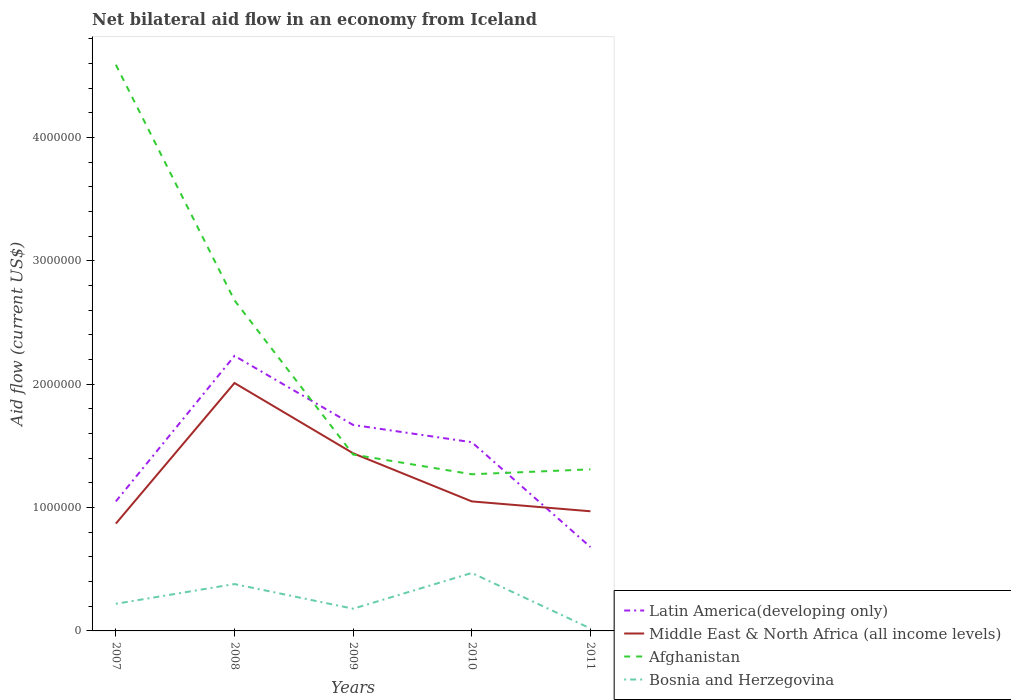Is the number of lines equal to the number of legend labels?
Keep it short and to the point. Yes. Across all years, what is the maximum net bilateral aid flow in Latin America(developing only)?
Offer a very short reply. 6.80e+05. In which year was the net bilateral aid flow in Middle East & North Africa (all income levels) maximum?
Give a very brief answer. 2007. What is the total net bilateral aid flow in Middle East & North Africa (all income levels) in the graph?
Ensure brevity in your answer.  4.70e+05. What is the difference between the highest and the second highest net bilateral aid flow in Middle East & North Africa (all income levels)?
Your answer should be compact. 1.14e+06. What is the difference between the highest and the lowest net bilateral aid flow in Middle East & North Africa (all income levels)?
Ensure brevity in your answer.  2. Is the net bilateral aid flow in Latin America(developing only) strictly greater than the net bilateral aid flow in Middle East & North Africa (all income levels) over the years?
Provide a short and direct response. No. How many lines are there?
Offer a terse response. 4. Does the graph contain any zero values?
Offer a terse response. No. Does the graph contain grids?
Provide a succinct answer. No. Where does the legend appear in the graph?
Your answer should be very brief. Bottom right. How many legend labels are there?
Your answer should be very brief. 4. How are the legend labels stacked?
Your answer should be very brief. Vertical. What is the title of the graph?
Keep it short and to the point. Net bilateral aid flow in an economy from Iceland. What is the label or title of the Y-axis?
Your answer should be compact. Aid flow (current US$). What is the Aid flow (current US$) of Latin America(developing only) in 2007?
Provide a succinct answer. 1.05e+06. What is the Aid flow (current US$) in Middle East & North Africa (all income levels) in 2007?
Provide a succinct answer. 8.70e+05. What is the Aid flow (current US$) in Afghanistan in 2007?
Provide a short and direct response. 4.59e+06. What is the Aid flow (current US$) of Bosnia and Herzegovina in 2007?
Ensure brevity in your answer.  2.20e+05. What is the Aid flow (current US$) of Latin America(developing only) in 2008?
Offer a terse response. 2.23e+06. What is the Aid flow (current US$) in Middle East & North Africa (all income levels) in 2008?
Ensure brevity in your answer.  2.01e+06. What is the Aid flow (current US$) of Afghanistan in 2008?
Your response must be concise. 2.68e+06. What is the Aid flow (current US$) in Latin America(developing only) in 2009?
Your answer should be very brief. 1.67e+06. What is the Aid flow (current US$) in Middle East & North Africa (all income levels) in 2009?
Your response must be concise. 1.44e+06. What is the Aid flow (current US$) of Afghanistan in 2009?
Offer a terse response. 1.43e+06. What is the Aid flow (current US$) of Bosnia and Herzegovina in 2009?
Your answer should be very brief. 1.80e+05. What is the Aid flow (current US$) in Latin America(developing only) in 2010?
Provide a short and direct response. 1.53e+06. What is the Aid flow (current US$) in Middle East & North Africa (all income levels) in 2010?
Your answer should be very brief. 1.05e+06. What is the Aid flow (current US$) of Afghanistan in 2010?
Your answer should be compact. 1.27e+06. What is the Aid flow (current US$) in Bosnia and Herzegovina in 2010?
Your response must be concise. 4.70e+05. What is the Aid flow (current US$) of Latin America(developing only) in 2011?
Give a very brief answer. 6.80e+05. What is the Aid flow (current US$) in Middle East & North Africa (all income levels) in 2011?
Give a very brief answer. 9.70e+05. What is the Aid flow (current US$) of Afghanistan in 2011?
Give a very brief answer. 1.31e+06. What is the Aid flow (current US$) of Bosnia and Herzegovina in 2011?
Ensure brevity in your answer.  2.00e+04. Across all years, what is the maximum Aid flow (current US$) of Latin America(developing only)?
Offer a terse response. 2.23e+06. Across all years, what is the maximum Aid flow (current US$) of Middle East & North Africa (all income levels)?
Give a very brief answer. 2.01e+06. Across all years, what is the maximum Aid flow (current US$) of Afghanistan?
Your answer should be very brief. 4.59e+06. Across all years, what is the maximum Aid flow (current US$) in Bosnia and Herzegovina?
Give a very brief answer. 4.70e+05. Across all years, what is the minimum Aid flow (current US$) in Latin America(developing only)?
Offer a very short reply. 6.80e+05. Across all years, what is the minimum Aid flow (current US$) of Middle East & North Africa (all income levels)?
Your answer should be very brief. 8.70e+05. Across all years, what is the minimum Aid flow (current US$) in Afghanistan?
Keep it short and to the point. 1.27e+06. What is the total Aid flow (current US$) of Latin America(developing only) in the graph?
Ensure brevity in your answer.  7.16e+06. What is the total Aid flow (current US$) in Middle East & North Africa (all income levels) in the graph?
Ensure brevity in your answer.  6.34e+06. What is the total Aid flow (current US$) in Afghanistan in the graph?
Keep it short and to the point. 1.13e+07. What is the total Aid flow (current US$) of Bosnia and Herzegovina in the graph?
Provide a succinct answer. 1.27e+06. What is the difference between the Aid flow (current US$) in Latin America(developing only) in 2007 and that in 2008?
Your response must be concise. -1.18e+06. What is the difference between the Aid flow (current US$) of Middle East & North Africa (all income levels) in 2007 and that in 2008?
Provide a succinct answer. -1.14e+06. What is the difference between the Aid flow (current US$) in Afghanistan in 2007 and that in 2008?
Keep it short and to the point. 1.91e+06. What is the difference between the Aid flow (current US$) of Bosnia and Herzegovina in 2007 and that in 2008?
Your answer should be very brief. -1.60e+05. What is the difference between the Aid flow (current US$) of Latin America(developing only) in 2007 and that in 2009?
Your answer should be very brief. -6.20e+05. What is the difference between the Aid flow (current US$) of Middle East & North Africa (all income levels) in 2007 and that in 2009?
Your answer should be very brief. -5.70e+05. What is the difference between the Aid flow (current US$) of Afghanistan in 2007 and that in 2009?
Your answer should be compact. 3.16e+06. What is the difference between the Aid flow (current US$) in Latin America(developing only) in 2007 and that in 2010?
Give a very brief answer. -4.80e+05. What is the difference between the Aid flow (current US$) of Afghanistan in 2007 and that in 2010?
Your response must be concise. 3.32e+06. What is the difference between the Aid flow (current US$) in Middle East & North Africa (all income levels) in 2007 and that in 2011?
Your answer should be compact. -1.00e+05. What is the difference between the Aid flow (current US$) in Afghanistan in 2007 and that in 2011?
Your answer should be very brief. 3.28e+06. What is the difference between the Aid flow (current US$) of Latin America(developing only) in 2008 and that in 2009?
Give a very brief answer. 5.60e+05. What is the difference between the Aid flow (current US$) of Middle East & North Africa (all income levels) in 2008 and that in 2009?
Offer a very short reply. 5.70e+05. What is the difference between the Aid flow (current US$) in Afghanistan in 2008 and that in 2009?
Keep it short and to the point. 1.25e+06. What is the difference between the Aid flow (current US$) in Bosnia and Herzegovina in 2008 and that in 2009?
Your response must be concise. 2.00e+05. What is the difference between the Aid flow (current US$) of Middle East & North Africa (all income levels) in 2008 and that in 2010?
Ensure brevity in your answer.  9.60e+05. What is the difference between the Aid flow (current US$) of Afghanistan in 2008 and that in 2010?
Your response must be concise. 1.41e+06. What is the difference between the Aid flow (current US$) of Bosnia and Herzegovina in 2008 and that in 2010?
Ensure brevity in your answer.  -9.00e+04. What is the difference between the Aid flow (current US$) of Latin America(developing only) in 2008 and that in 2011?
Ensure brevity in your answer.  1.55e+06. What is the difference between the Aid flow (current US$) in Middle East & North Africa (all income levels) in 2008 and that in 2011?
Provide a short and direct response. 1.04e+06. What is the difference between the Aid flow (current US$) of Afghanistan in 2008 and that in 2011?
Provide a succinct answer. 1.37e+06. What is the difference between the Aid flow (current US$) of Bosnia and Herzegovina in 2008 and that in 2011?
Your answer should be compact. 3.60e+05. What is the difference between the Aid flow (current US$) of Latin America(developing only) in 2009 and that in 2010?
Make the answer very short. 1.40e+05. What is the difference between the Aid flow (current US$) in Afghanistan in 2009 and that in 2010?
Your answer should be very brief. 1.60e+05. What is the difference between the Aid flow (current US$) of Bosnia and Herzegovina in 2009 and that in 2010?
Provide a succinct answer. -2.90e+05. What is the difference between the Aid flow (current US$) in Latin America(developing only) in 2009 and that in 2011?
Keep it short and to the point. 9.90e+05. What is the difference between the Aid flow (current US$) of Afghanistan in 2009 and that in 2011?
Provide a short and direct response. 1.20e+05. What is the difference between the Aid flow (current US$) in Bosnia and Herzegovina in 2009 and that in 2011?
Your answer should be compact. 1.60e+05. What is the difference between the Aid flow (current US$) in Latin America(developing only) in 2010 and that in 2011?
Keep it short and to the point. 8.50e+05. What is the difference between the Aid flow (current US$) in Middle East & North Africa (all income levels) in 2010 and that in 2011?
Ensure brevity in your answer.  8.00e+04. What is the difference between the Aid flow (current US$) of Afghanistan in 2010 and that in 2011?
Make the answer very short. -4.00e+04. What is the difference between the Aid flow (current US$) of Latin America(developing only) in 2007 and the Aid flow (current US$) of Middle East & North Africa (all income levels) in 2008?
Your answer should be compact. -9.60e+05. What is the difference between the Aid flow (current US$) of Latin America(developing only) in 2007 and the Aid flow (current US$) of Afghanistan in 2008?
Your answer should be very brief. -1.63e+06. What is the difference between the Aid flow (current US$) in Latin America(developing only) in 2007 and the Aid flow (current US$) in Bosnia and Herzegovina in 2008?
Your answer should be compact. 6.70e+05. What is the difference between the Aid flow (current US$) of Middle East & North Africa (all income levels) in 2007 and the Aid flow (current US$) of Afghanistan in 2008?
Your response must be concise. -1.81e+06. What is the difference between the Aid flow (current US$) in Middle East & North Africa (all income levels) in 2007 and the Aid flow (current US$) in Bosnia and Herzegovina in 2008?
Your answer should be very brief. 4.90e+05. What is the difference between the Aid flow (current US$) in Afghanistan in 2007 and the Aid flow (current US$) in Bosnia and Herzegovina in 2008?
Ensure brevity in your answer.  4.21e+06. What is the difference between the Aid flow (current US$) in Latin America(developing only) in 2007 and the Aid flow (current US$) in Middle East & North Africa (all income levels) in 2009?
Your answer should be very brief. -3.90e+05. What is the difference between the Aid flow (current US$) in Latin America(developing only) in 2007 and the Aid flow (current US$) in Afghanistan in 2009?
Offer a very short reply. -3.80e+05. What is the difference between the Aid flow (current US$) in Latin America(developing only) in 2007 and the Aid flow (current US$) in Bosnia and Herzegovina in 2009?
Offer a very short reply. 8.70e+05. What is the difference between the Aid flow (current US$) in Middle East & North Africa (all income levels) in 2007 and the Aid flow (current US$) in Afghanistan in 2009?
Your answer should be compact. -5.60e+05. What is the difference between the Aid flow (current US$) in Middle East & North Africa (all income levels) in 2007 and the Aid flow (current US$) in Bosnia and Herzegovina in 2009?
Your answer should be very brief. 6.90e+05. What is the difference between the Aid flow (current US$) in Afghanistan in 2007 and the Aid flow (current US$) in Bosnia and Herzegovina in 2009?
Make the answer very short. 4.41e+06. What is the difference between the Aid flow (current US$) of Latin America(developing only) in 2007 and the Aid flow (current US$) of Middle East & North Africa (all income levels) in 2010?
Offer a very short reply. 0. What is the difference between the Aid flow (current US$) of Latin America(developing only) in 2007 and the Aid flow (current US$) of Afghanistan in 2010?
Provide a succinct answer. -2.20e+05. What is the difference between the Aid flow (current US$) in Latin America(developing only) in 2007 and the Aid flow (current US$) in Bosnia and Herzegovina in 2010?
Offer a very short reply. 5.80e+05. What is the difference between the Aid flow (current US$) of Middle East & North Africa (all income levels) in 2007 and the Aid flow (current US$) of Afghanistan in 2010?
Your answer should be very brief. -4.00e+05. What is the difference between the Aid flow (current US$) of Middle East & North Africa (all income levels) in 2007 and the Aid flow (current US$) of Bosnia and Herzegovina in 2010?
Your response must be concise. 4.00e+05. What is the difference between the Aid flow (current US$) of Afghanistan in 2007 and the Aid flow (current US$) of Bosnia and Herzegovina in 2010?
Your answer should be very brief. 4.12e+06. What is the difference between the Aid flow (current US$) in Latin America(developing only) in 2007 and the Aid flow (current US$) in Middle East & North Africa (all income levels) in 2011?
Offer a very short reply. 8.00e+04. What is the difference between the Aid flow (current US$) of Latin America(developing only) in 2007 and the Aid flow (current US$) of Bosnia and Herzegovina in 2011?
Your answer should be very brief. 1.03e+06. What is the difference between the Aid flow (current US$) of Middle East & North Africa (all income levels) in 2007 and the Aid flow (current US$) of Afghanistan in 2011?
Ensure brevity in your answer.  -4.40e+05. What is the difference between the Aid flow (current US$) in Middle East & North Africa (all income levels) in 2007 and the Aid flow (current US$) in Bosnia and Herzegovina in 2011?
Your answer should be very brief. 8.50e+05. What is the difference between the Aid flow (current US$) of Afghanistan in 2007 and the Aid flow (current US$) of Bosnia and Herzegovina in 2011?
Give a very brief answer. 4.57e+06. What is the difference between the Aid flow (current US$) in Latin America(developing only) in 2008 and the Aid flow (current US$) in Middle East & North Africa (all income levels) in 2009?
Keep it short and to the point. 7.90e+05. What is the difference between the Aid flow (current US$) of Latin America(developing only) in 2008 and the Aid flow (current US$) of Bosnia and Herzegovina in 2009?
Keep it short and to the point. 2.05e+06. What is the difference between the Aid flow (current US$) of Middle East & North Africa (all income levels) in 2008 and the Aid flow (current US$) of Afghanistan in 2009?
Make the answer very short. 5.80e+05. What is the difference between the Aid flow (current US$) of Middle East & North Africa (all income levels) in 2008 and the Aid flow (current US$) of Bosnia and Herzegovina in 2009?
Provide a succinct answer. 1.83e+06. What is the difference between the Aid flow (current US$) in Afghanistan in 2008 and the Aid flow (current US$) in Bosnia and Herzegovina in 2009?
Provide a succinct answer. 2.50e+06. What is the difference between the Aid flow (current US$) of Latin America(developing only) in 2008 and the Aid flow (current US$) of Middle East & North Africa (all income levels) in 2010?
Provide a short and direct response. 1.18e+06. What is the difference between the Aid flow (current US$) in Latin America(developing only) in 2008 and the Aid flow (current US$) in Afghanistan in 2010?
Your answer should be compact. 9.60e+05. What is the difference between the Aid flow (current US$) of Latin America(developing only) in 2008 and the Aid flow (current US$) of Bosnia and Herzegovina in 2010?
Offer a very short reply. 1.76e+06. What is the difference between the Aid flow (current US$) in Middle East & North Africa (all income levels) in 2008 and the Aid flow (current US$) in Afghanistan in 2010?
Give a very brief answer. 7.40e+05. What is the difference between the Aid flow (current US$) of Middle East & North Africa (all income levels) in 2008 and the Aid flow (current US$) of Bosnia and Herzegovina in 2010?
Provide a short and direct response. 1.54e+06. What is the difference between the Aid flow (current US$) in Afghanistan in 2008 and the Aid flow (current US$) in Bosnia and Herzegovina in 2010?
Offer a terse response. 2.21e+06. What is the difference between the Aid flow (current US$) of Latin America(developing only) in 2008 and the Aid flow (current US$) of Middle East & North Africa (all income levels) in 2011?
Your response must be concise. 1.26e+06. What is the difference between the Aid flow (current US$) of Latin America(developing only) in 2008 and the Aid flow (current US$) of Afghanistan in 2011?
Your answer should be compact. 9.20e+05. What is the difference between the Aid flow (current US$) in Latin America(developing only) in 2008 and the Aid flow (current US$) in Bosnia and Herzegovina in 2011?
Offer a very short reply. 2.21e+06. What is the difference between the Aid flow (current US$) in Middle East & North Africa (all income levels) in 2008 and the Aid flow (current US$) in Bosnia and Herzegovina in 2011?
Your answer should be very brief. 1.99e+06. What is the difference between the Aid flow (current US$) of Afghanistan in 2008 and the Aid flow (current US$) of Bosnia and Herzegovina in 2011?
Make the answer very short. 2.66e+06. What is the difference between the Aid flow (current US$) of Latin America(developing only) in 2009 and the Aid flow (current US$) of Middle East & North Africa (all income levels) in 2010?
Provide a succinct answer. 6.20e+05. What is the difference between the Aid flow (current US$) in Latin America(developing only) in 2009 and the Aid flow (current US$) in Bosnia and Herzegovina in 2010?
Make the answer very short. 1.20e+06. What is the difference between the Aid flow (current US$) in Middle East & North Africa (all income levels) in 2009 and the Aid flow (current US$) in Afghanistan in 2010?
Provide a succinct answer. 1.70e+05. What is the difference between the Aid flow (current US$) of Middle East & North Africa (all income levels) in 2009 and the Aid flow (current US$) of Bosnia and Herzegovina in 2010?
Provide a short and direct response. 9.70e+05. What is the difference between the Aid flow (current US$) in Afghanistan in 2009 and the Aid flow (current US$) in Bosnia and Herzegovina in 2010?
Give a very brief answer. 9.60e+05. What is the difference between the Aid flow (current US$) of Latin America(developing only) in 2009 and the Aid flow (current US$) of Bosnia and Herzegovina in 2011?
Ensure brevity in your answer.  1.65e+06. What is the difference between the Aid flow (current US$) of Middle East & North Africa (all income levels) in 2009 and the Aid flow (current US$) of Bosnia and Herzegovina in 2011?
Offer a very short reply. 1.42e+06. What is the difference between the Aid flow (current US$) of Afghanistan in 2009 and the Aid flow (current US$) of Bosnia and Herzegovina in 2011?
Offer a terse response. 1.41e+06. What is the difference between the Aid flow (current US$) in Latin America(developing only) in 2010 and the Aid flow (current US$) in Middle East & North Africa (all income levels) in 2011?
Keep it short and to the point. 5.60e+05. What is the difference between the Aid flow (current US$) in Latin America(developing only) in 2010 and the Aid flow (current US$) in Bosnia and Herzegovina in 2011?
Keep it short and to the point. 1.51e+06. What is the difference between the Aid flow (current US$) in Middle East & North Africa (all income levels) in 2010 and the Aid flow (current US$) in Afghanistan in 2011?
Offer a very short reply. -2.60e+05. What is the difference between the Aid flow (current US$) in Middle East & North Africa (all income levels) in 2010 and the Aid flow (current US$) in Bosnia and Herzegovina in 2011?
Keep it short and to the point. 1.03e+06. What is the difference between the Aid flow (current US$) of Afghanistan in 2010 and the Aid flow (current US$) of Bosnia and Herzegovina in 2011?
Your answer should be very brief. 1.25e+06. What is the average Aid flow (current US$) of Latin America(developing only) per year?
Provide a short and direct response. 1.43e+06. What is the average Aid flow (current US$) in Middle East & North Africa (all income levels) per year?
Offer a very short reply. 1.27e+06. What is the average Aid flow (current US$) in Afghanistan per year?
Ensure brevity in your answer.  2.26e+06. What is the average Aid flow (current US$) in Bosnia and Herzegovina per year?
Your response must be concise. 2.54e+05. In the year 2007, what is the difference between the Aid flow (current US$) in Latin America(developing only) and Aid flow (current US$) in Afghanistan?
Offer a terse response. -3.54e+06. In the year 2007, what is the difference between the Aid flow (current US$) of Latin America(developing only) and Aid flow (current US$) of Bosnia and Herzegovina?
Make the answer very short. 8.30e+05. In the year 2007, what is the difference between the Aid flow (current US$) in Middle East & North Africa (all income levels) and Aid flow (current US$) in Afghanistan?
Your answer should be compact. -3.72e+06. In the year 2007, what is the difference between the Aid flow (current US$) in Middle East & North Africa (all income levels) and Aid flow (current US$) in Bosnia and Herzegovina?
Offer a very short reply. 6.50e+05. In the year 2007, what is the difference between the Aid flow (current US$) of Afghanistan and Aid flow (current US$) of Bosnia and Herzegovina?
Offer a very short reply. 4.37e+06. In the year 2008, what is the difference between the Aid flow (current US$) in Latin America(developing only) and Aid flow (current US$) in Afghanistan?
Your answer should be very brief. -4.50e+05. In the year 2008, what is the difference between the Aid flow (current US$) of Latin America(developing only) and Aid flow (current US$) of Bosnia and Herzegovina?
Offer a very short reply. 1.85e+06. In the year 2008, what is the difference between the Aid flow (current US$) of Middle East & North Africa (all income levels) and Aid flow (current US$) of Afghanistan?
Your answer should be very brief. -6.70e+05. In the year 2008, what is the difference between the Aid flow (current US$) in Middle East & North Africa (all income levels) and Aid flow (current US$) in Bosnia and Herzegovina?
Give a very brief answer. 1.63e+06. In the year 2008, what is the difference between the Aid flow (current US$) in Afghanistan and Aid flow (current US$) in Bosnia and Herzegovina?
Keep it short and to the point. 2.30e+06. In the year 2009, what is the difference between the Aid flow (current US$) in Latin America(developing only) and Aid flow (current US$) in Middle East & North Africa (all income levels)?
Provide a succinct answer. 2.30e+05. In the year 2009, what is the difference between the Aid flow (current US$) of Latin America(developing only) and Aid flow (current US$) of Afghanistan?
Offer a very short reply. 2.40e+05. In the year 2009, what is the difference between the Aid flow (current US$) of Latin America(developing only) and Aid flow (current US$) of Bosnia and Herzegovina?
Keep it short and to the point. 1.49e+06. In the year 2009, what is the difference between the Aid flow (current US$) of Middle East & North Africa (all income levels) and Aid flow (current US$) of Bosnia and Herzegovina?
Provide a succinct answer. 1.26e+06. In the year 2009, what is the difference between the Aid flow (current US$) of Afghanistan and Aid flow (current US$) of Bosnia and Herzegovina?
Keep it short and to the point. 1.25e+06. In the year 2010, what is the difference between the Aid flow (current US$) of Latin America(developing only) and Aid flow (current US$) of Middle East & North Africa (all income levels)?
Ensure brevity in your answer.  4.80e+05. In the year 2010, what is the difference between the Aid flow (current US$) of Latin America(developing only) and Aid flow (current US$) of Afghanistan?
Your answer should be very brief. 2.60e+05. In the year 2010, what is the difference between the Aid flow (current US$) of Latin America(developing only) and Aid flow (current US$) of Bosnia and Herzegovina?
Provide a succinct answer. 1.06e+06. In the year 2010, what is the difference between the Aid flow (current US$) in Middle East & North Africa (all income levels) and Aid flow (current US$) in Afghanistan?
Your answer should be very brief. -2.20e+05. In the year 2010, what is the difference between the Aid flow (current US$) in Middle East & North Africa (all income levels) and Aid flow (current US$) in Bosnia and Herzegovina?
Provide a succinct answer. 5.80e+05. In the year 2010, what is the difference between the Aid flow (current US$) in Afghanistan and Aid flow (current US$) in Bosnia and Herzegovina?
Provide a succinct answer. 8.00e+05. In the year 2011, what is the difference between the Aid flow (current US$) in Latin America(developing only) and Aid flow (current US$) in Middle East & North Africa (all income levels)?
Your answer should be compact. -2.90e+05. In the year 2011, what is the difference between the Aid flow (current US$) of Latin America(developing only) and Aid flow (current US$) of Afghanistan?
Your answer should be very brief. -6.30e+05. In the year 2011, what is the difference between the Aid flow (current US$) of Latin America(developing only) and Aid flow (current US$) of Bosnia and Herzegovina?
Your answer should be compact. 6.60e+05. In the year 2011, what is the difference between the Aid flow (current US$) of Middle East & North Africa (all income levels) and Aid flow (current US$) of Afghanistan?
Keep it short and to the point. -3.40e+05. In the year 2011, what is the difference between the Aid flow (current US$) in Middle East & North Africa (all income levels) and Aid flow (current US$) in Bosnia and Herzegovina?
Give a very brief answer. 9.50e+05. In the year 2011, what is the difference between the Aid flow (current US$) in Afghanistan and Aid flow (current US$) in Bosnia and Herzegovina?
Your answer should be very brief. 1.29e+06. What is the ratio of the Aid flow (current US$) of Latin America(developing only) in 2007 to that in 2008?
Provide a succinct answer. 0.47. What is the ratio of the Aid flow (current US$) in Middle East & North Africa (all income levels) in 2007 to that in 2008?
Provide a succinct answer. 0.43. What is the ratio of the Aid flow (current US$) of Afghanistan in 2007 to that in 2008?
Make the answer very short. 1.71. What is the ratio of the Aid flow (current US$) in Bosnia and Herzegovina in 2007 to that in 2008?
Your answer should be compact. 0.58. What is the ratio of the Aid flow (current US$) of Latin America(developing only) in 2007 to that in 2009?
Offer a very short reply. 0.63. What is the ratio of the Aid flow (current US$) in Middle East & North Africa (all income levels) in 2007 to that in 2009?
Ensure brevity in your answer.  0.6. What is the ratio of the Aid flow (current US$) in Afghanistan in 2007 to that in 2009?
Your response must be concise. 3.21. What is the ratio of the Aid flow (current US$) in Bosnia and Herzegovina in 2007 to that in 2009?
Your response must be concise. 1.22. What is the ratio of the Aid flow (current US$) of Latin America(developing only) in 2007 to that in 2010?
Offer a very short reply. 0.69. What is the ratio of the Aid flow (current US$) of Middle East & North Africa (all income levels) in 2007 to that in 2010?
Your answer should be very brief. 0.83. What is the ratio of the Aid flow (current US$) in Afghanistan in 2007 to that in 2010?
Your answer should be very brief. 3.61. What is the ratio of the Aid flow (current US$) in Bosnia and Herzegovina in 2007 to that in 2010?
Make the answer very short. 0.47. What is the ratio of the Aid flow (current US$) in Latin America(developing only) in 2007 to that in 2011?
Give a very brief answer. 1.54. What is the ratio of the Aid flow (current US$) of Middle East & North Africa (all income levels) in 2007 to that in 2011?
Offer a very short reply. 0.9. What is the ratio of the Aid flow (current US$) in Afghanistan in 2007 to that in 2011?
Your answer should be compact. 3.5. What is the ratio of the Aid flow (current US$) in Bosnia and Herzegovina in 2007 to that in 2011?
Make the answer very short. 11. What is the ratio of the Aid flow (current US$) of Latin America(developing only) in 2008 to that in 2009?
Offer a terse response. 1.34. What is the ratio of the Aid flow (current US$) of Middle East & North Africa (all income levels) in 2008 to that in 2009?
Provide a succinct answer. 1.4. What is the ratio of the Aid flow (current US$) of Afghanistan in 2008 to that in 2009?
Your response must be concise. 1.87. What is the ratio of the Aid flow (current US$) of Bosnia and Herzegovina in 2008 to that in 2009?
Keep it short and to the point. 2.11. What is the ratio of the Aid flow (current US$) in Latin America(developing only) in 2008 to that in 2010?
Offer a terse response. 1.46. What is the ratio of the Aid flow (current US$) in Middle East & North Africa (all income levels) in 2008 to that in 2010?
Your response must be concise. 1.91. What is the ratio of the Aid flow (current US$) in Afghanistan in 2008 to that in 2010?
Make the answer very short. 2.11. What is the ratio of the Aid flow (current US$) in Bosnia and Herzegovina in 2008 to that in 2010?
Offer a terse response. 0.81. What is the ratio of the Aid flow (current US$) in Latin America(developing only) in 2008 to that in 2011?
Your answer should be very brief. 3.28. What is the ratio of the Aid flow (current US$) of Middle East & North Africa (all income levels) in 2008 to that in 2011?
Your response must be concise. 2.07. What is the ratio of the Aid flow (current US$) of Afghanistan in 2008 to that in 2011?
Make the answer very short. 2.05. What is the ratio of the Aid flow (current US$) of Bosnia and Herzegovina in 2008 to that in 2011?
Offer a very short reply. 19. What is the ratio of the Aid flow (current US$) in Latin America(developing only) in 2009 to that in 2010?
Keep it short and to the point. 1.09. What is the ratio of the Aid flow (current US$) of Middle East & North Africa (all income levels) in 2009 to that in 2010?
Provide a short and direct response. 1.37. What is the ratio of the Aid flow (current US$) of Afghanistan in 2009 to that in 2010?
Your answer should be compact. 1.13. What is the ratio of the Aid flow (current US$) in Bosnia and Herzegovina in 2009 to that in 2010?
Ensure brevity in your answer.  0.38. What is the ratio of the Aid flow (current US$) in Latin America(developing only) in 2009 to that in 2011?
Your answer should be compact. 2.46. What is the ratio of the Aid flow (current US$) of Middle East & North Africa (all income levels) in 2009 to that in 2011?
Your response must be concise. 1.48. What is the ratio of the Aid flow (current US$) in Afghanistan in 2009 to that in 2011?
Offer a very short reply. 1.09. What is the ratio of the Aid flow (current US$) of Latin America(developing only) in 2010 to that in 2011?
Your answer should be very brief. 2.25. What is the ratio of the Aid flow (current US$) of Middle East & North Africa (all income levels) in 2010 to that in 2011?
Offer a terse response. 1.08. What is the ratio of the Aid flow (current US$) of Afghanistan in 2010 to that in 2011?
Give a very brief answer. 0.97. What is the difference between the highest and the second highest Aid flow (current US$) in Latin America(developing only)?
Provide a short and direct response. 5.60e+05. What is the difference between the highest and the second highest Aid flow (current US$) in Middle East & North Africa (all income levels)?
Your response must be concise. 5.70e+05. What is the difference between the highest and the second highest Aid flow (current US$) of Afghanistan?
Provide a short and direct response. 1.91e+06. What is the difference between the highest and the lowest Aid flow (current US$) of Latin America(developing only)?
Provide a succinct answer. 1.55e+06. What is the difference between the highest and the lowest Aid flow (current US$) in Middle East & North Africa (all income levels)?
Provide a succinct answer. 1.14e+06. What is the difference between the highest and the lowest Aid flow (current US$) of Afghanistan?
Your response must be concise. 3.32e+06. 